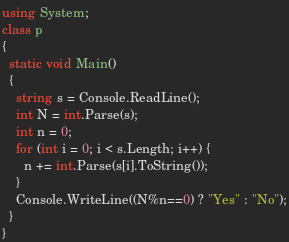Convert code to text. <code><loc_0><loc_0><loc_500><loc_500><_C#_>using System;
class p
{
  static void Main()
  {
    string s = Console.ReadLine();
    int N = int.Parse(s);
    int n = 0;
    for (int i = 0; i < s.Length; i++) {
      n += int.Parse(s[i].ToString());
    }
    Console.WriteLine((N%n==0) ? "Yes" : "No");
  }
}</code> 